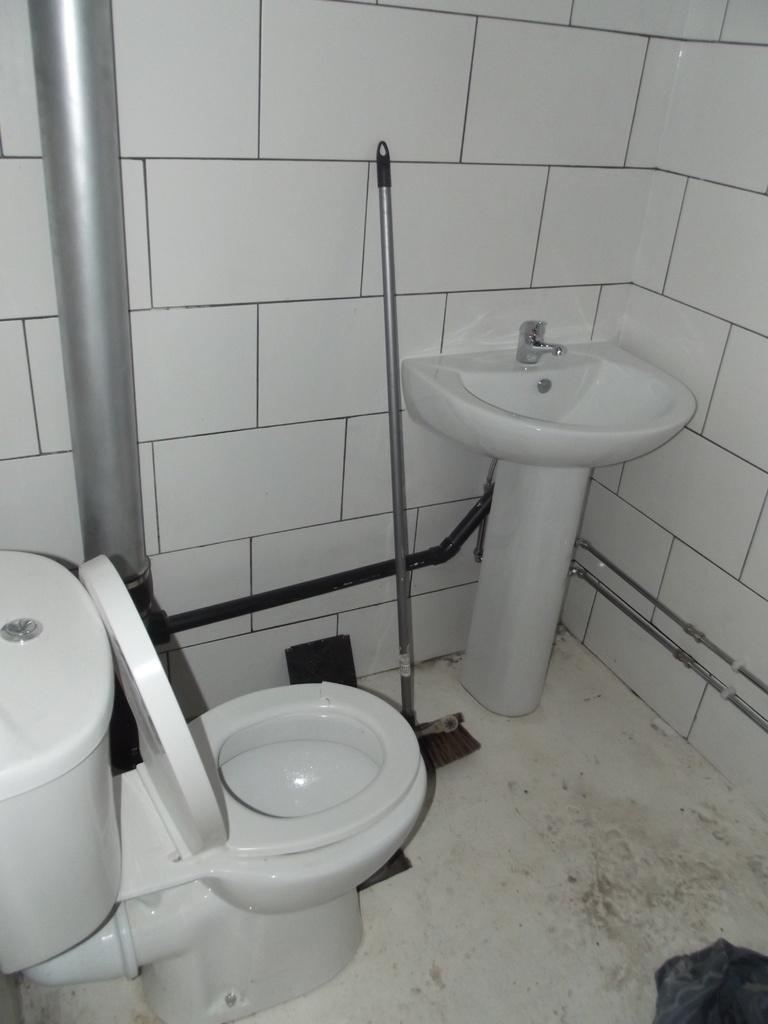Could you give a brief overview of what you see in this image? In this image, we can see the inner view of a bathroom. We can see the ground with some objects. We can see the wall. We can also see a sweep morph, a pole and an object at the bottom right corner. 